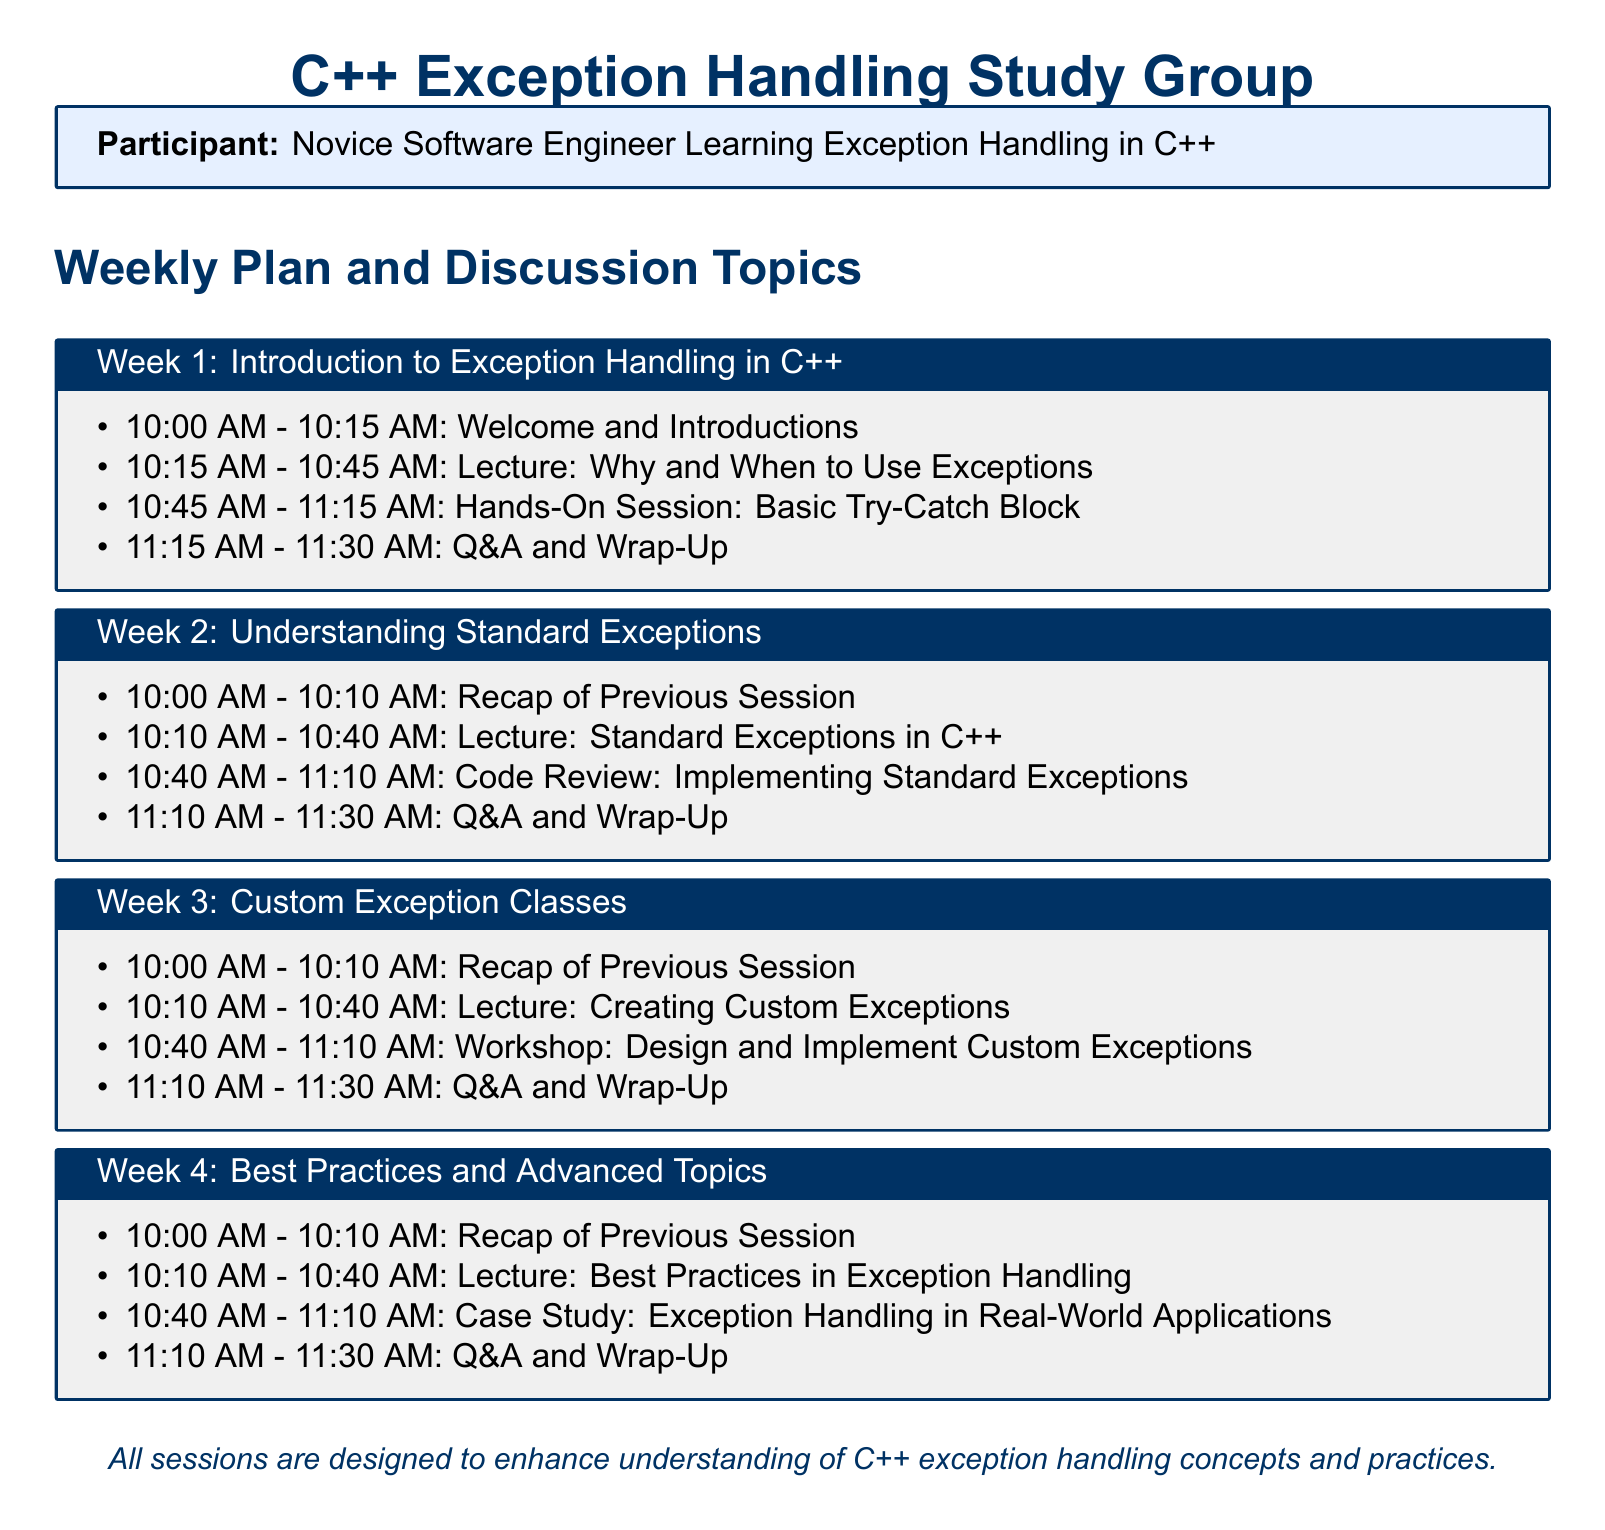What is the title of the study group? The title of the study group is presented at the top of the document.
Answer: C++ Exception Handling Study Group Who is the participant listed in the document? The participant's role is specified within the tcolorbox that describes them.
Answer: Novice Software Engineer Learning Exception Handling in C++ How long is the Welcome and Introductions session in Week 1? The duration of the session is indicated in the schedule for Week 1.
Answer: 15 minutes What is the main topic of Week 4? The main topic is outlined with a title in the corresponding tcolorbox.
Answer: Best Practices and Advanced Topics Which session includes a hands-on exercise? The hands-on exercise is mentioned in Week 1's schedule.
Answer: Week 1 How many minutes are allocated for the Code Review in Week 2? The duration of the Code Review session can be found in the Week 2 schedule.
Answer: 30 minutes What is the first activity in Week 3? The first activity in Week 3 is listed in the agenda for that week.
Answer: Recap of Previous Session How many sessions are there in total? The number of sessions can be determined by counting the weeks presented in the document.
Answer: 4 sessions What is the ending time for the Q&A and Wrap-Up in Week 4? The ending time is specified in the schedule for Week 4.
Answer: 11:30 AM 